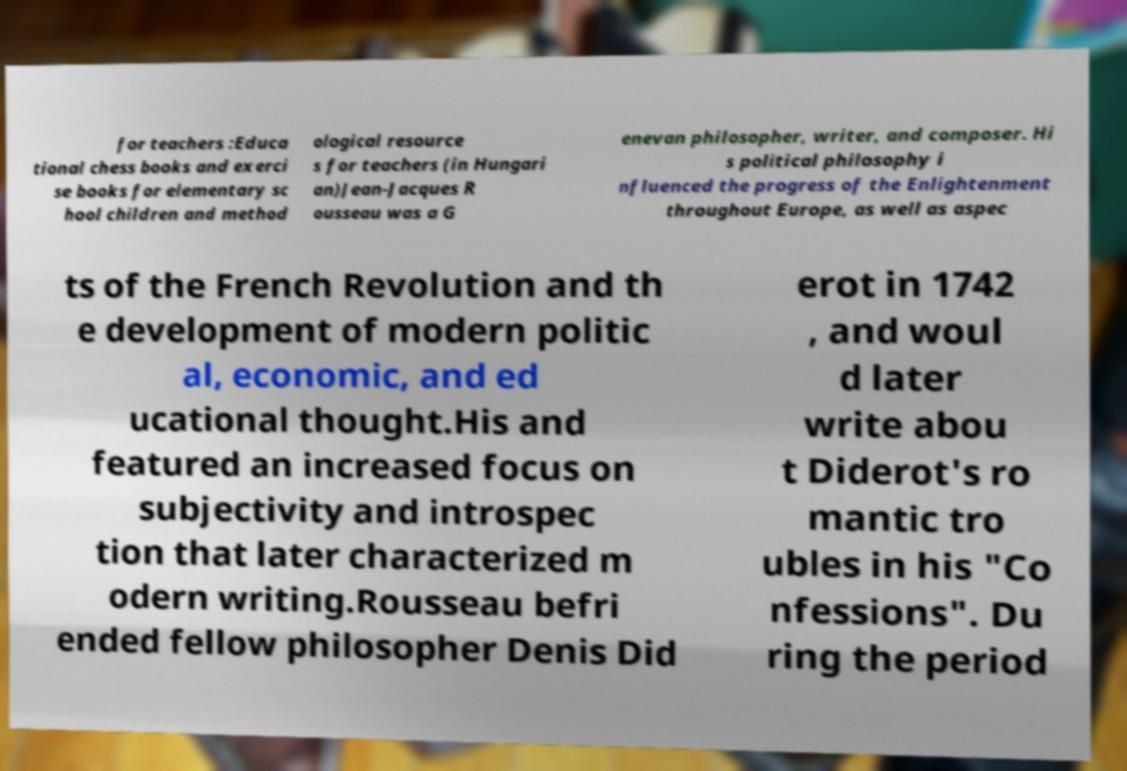There's text embedded in this image that I need extracted. Can you transcribe it verbatim? for teachers :Educa tional chess books and exerci se books for elementary sc hool children and method ological resource s for teachers (in Hungari an)Jean-Jacques R ousseau was a G enevan philosopher, writer, and composer. Hi s political philosophy i nfluenced the progress of the Enlightenment throughout Europe, as well as aspec ts of the French Revolution and th e development of modern politic al, economic, and ed ucational thought.His and featured an increased focus on subjectivity and introspec tion that later characterized m odern writing.Rousseau befri ended fellow philosopher Denis Did erot in 1742 , and woul d later write abou t Diderot's ro mantic tro ubles in his "Co nfessions". Du ring the period 